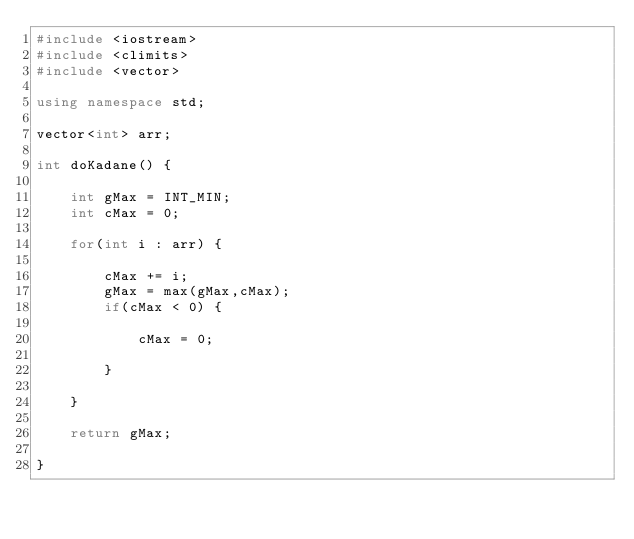Convert code to text. <code><loc_0><loc_0><loc_500><loc_500><_C++_>#include <iostream>
#include <climits>
#include <vector>

using namespace std;

vector<int> arr;

int doKadane() {
    
    int gMax = INT_MIN;
    int cMax = 0;
    
    for(int i : arr) {
        
        cMax += i;
        gMax = max(gMax,cMax);
        if(cMax < 0) {
            
            cMax = 0;
            
        }
        
    }
    
    return gMax;
    
}
</code> 